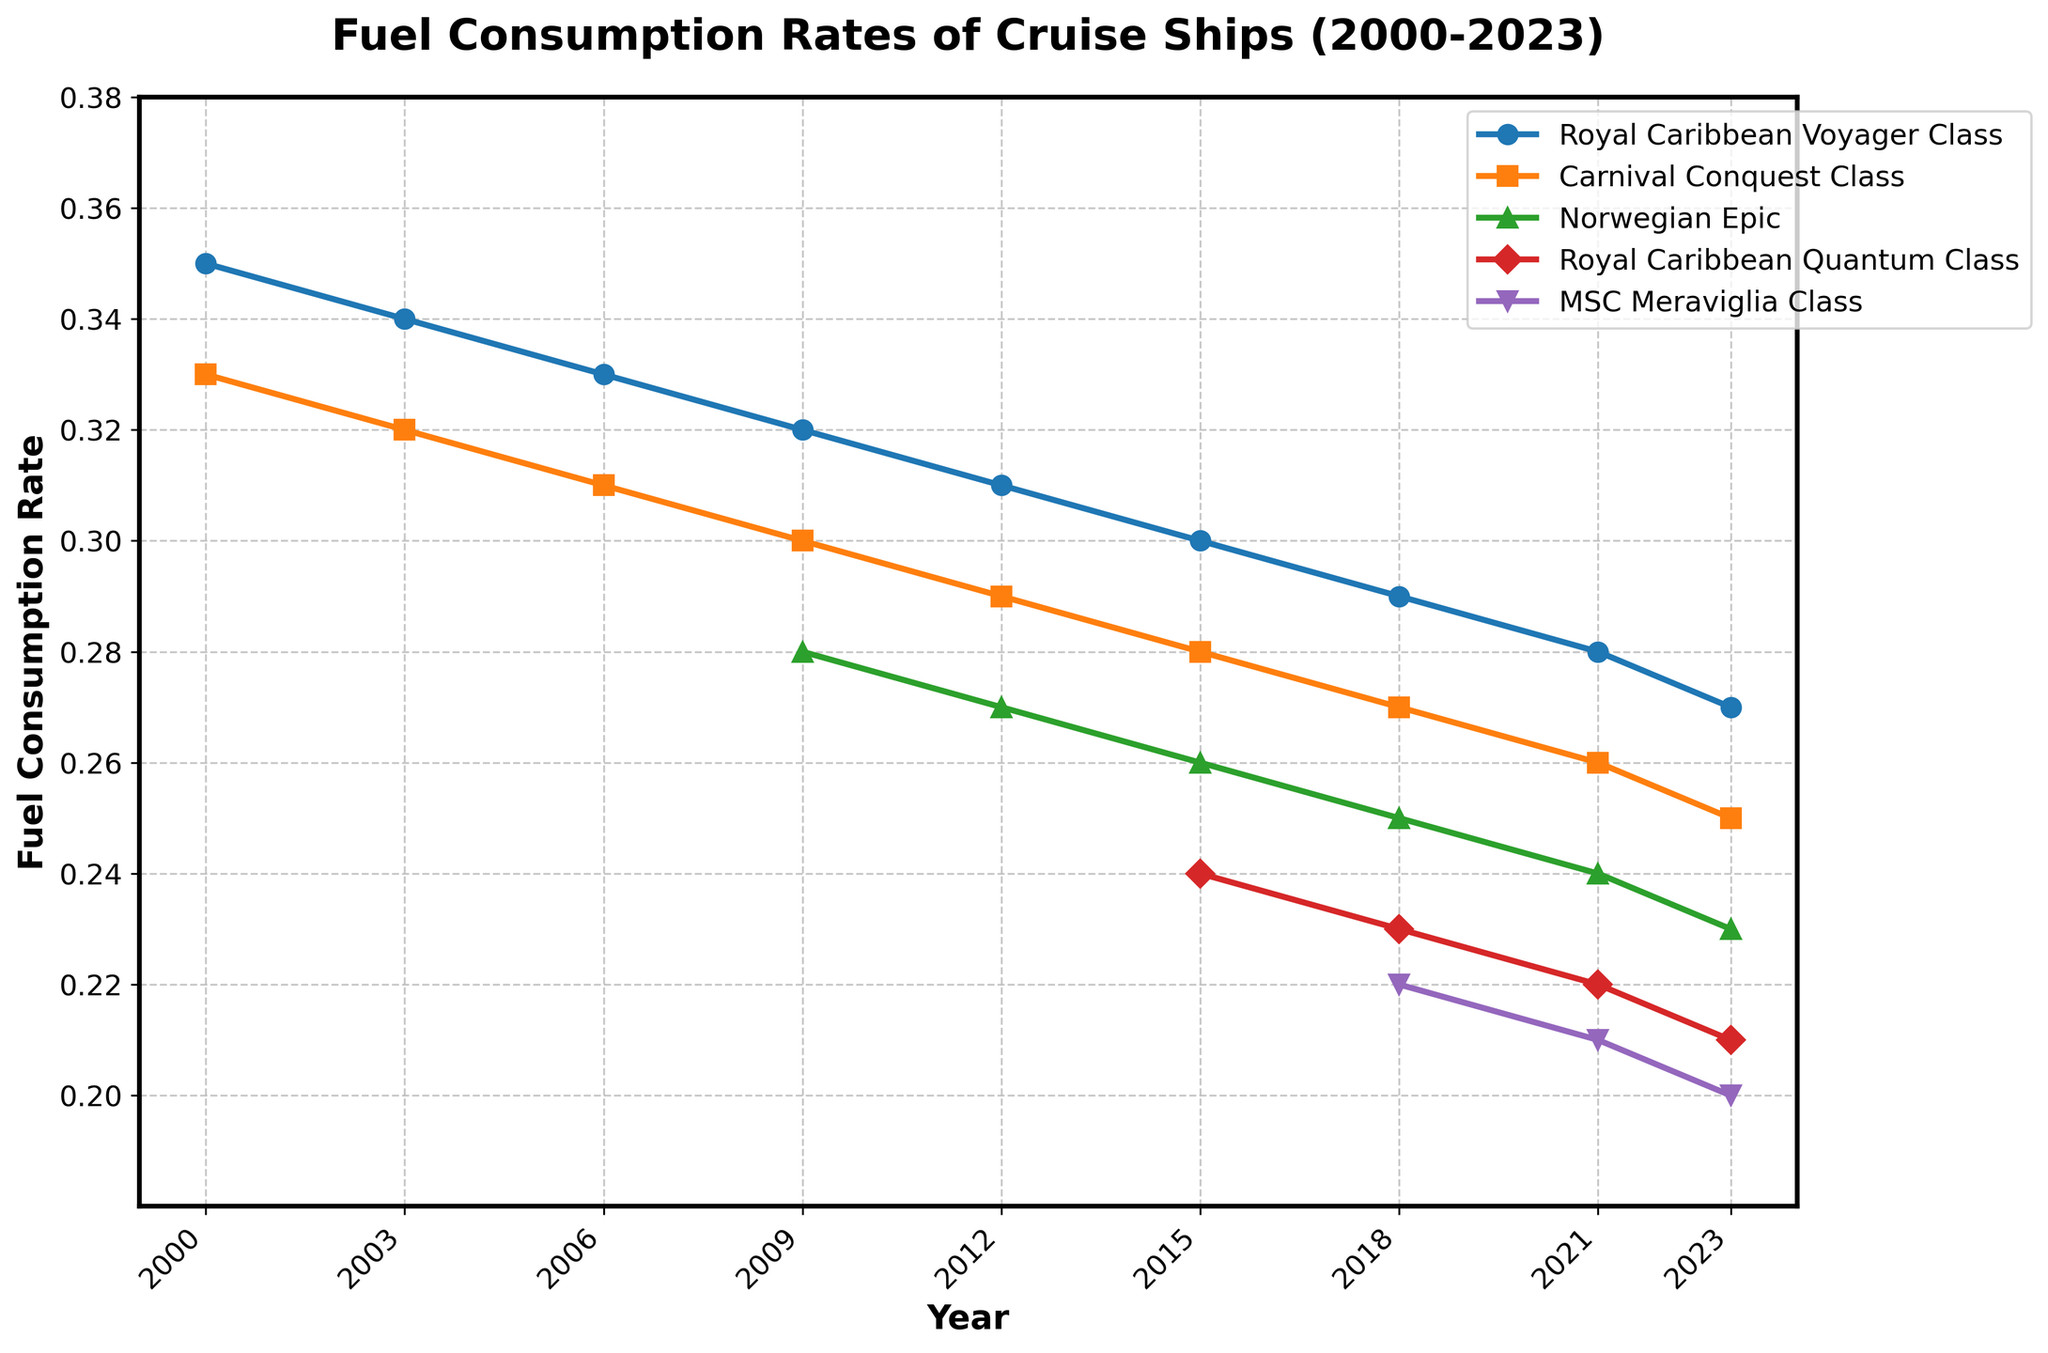Which cruise ship model maintains the highest fuel consumption rate throughout the years? By examining the plot, the Royal Caribbean Voyager Class consistently has the highest line, indicating the highest consumption rate.
Answer: Royal Caribbean Voyager Class Compare the fuel consumption rates of Royal Caribbean Quantum Class and MSC Meraviglia Class in 2023. Which one is more efficient? In 2023, the Royal Caribbean Quantum Class has a consumption rate of 0.21, while MSC Meraviglia Class has a lower rate of 0.20. Lower fuel consumption rate implies more efficiency.
Answer: MSC Meraviglia Class Has the Norwegian Epic model seen a decrease in fuel consumption from 2009 to 2023, and by how much? From the figure, the Norwegian Epic starts with a rate of 0.28 in 2009 and decreases to 0.23 in 2023. Subtracting these values gives the decrease: 0.28 - 0.23 = 0.05.
Answer: 0.05 What is the average fuel consumption rate of the Carnival Conquest Class from 2000 to 2023? The rates from 2000 to 2023 are 0.33, 0.32, 0.31, 0.30, 0.29, 0.28, 0.27, 0.26, and 0.25. Summing these values and dividing by the number of years (9) gives the average: (0.33 + 0.32 + 0.31 + 0.30 + 0.29 + 0.28 + 0.27 + 0.26 + 0.25) / 9 ≈ 0.29.
Answer: 0.29 Which cruise ship model has the most significant decrease in fuel consumption rate from its initial year to 2023? Calculate the initial and final rates for each model: 
- Royal Caribbean Voyager Class: 0.35 - 0.27 = 0.08
- Carnival Conquest Class: 0.33 - 0.25 = 0.08
- Norwegian Epic: 0.28 - 0.23 = 0.05
- Royal Caribbean Quantum Class: 0.24 - 0.21 = 0.03
- MSC Meraviglia Class: 0.22 - 0.20 = 0.02
Both Royal Caribbean Voyager Class and Carnival Conquest Class have the most significant decrease of 0.08.
Answer: Royal Caribbean Voyager Class and Carnival Conquest Class How has the fuel consumption rate trend for traditional models (2000-2009) compared to newer models (2015-2023)? Traditional models, indicated by Royal Caribbean Voyager Class and Carnival Conquest Class, show a gradual decrease from higher rates (0.35 to 0.32 and 0.33 to 0.30). Newer models, exemplified by Royal Caribbean Quantum Class and MSC Meraviglia Class, start with lower initial rates (0.24 and 0.22) and also show a gradual decrease indicating more efficient designs from the beginning.
Answer: Newer models are initially more efficient and continue to improve Between 2018 and 2023, how much did the fuel consumption rate decrease for the Royal Caribbean Quantum Class? The rates for Royal Caribbean Quantum Class in 2018 and 2023 are 0.23 and 0.21 respectively. Subtracting these values gives the decrease: 0.23 - 0.21 = 0.02.
Answer: 0.02 Which model has the steadiest decrease in fuel consumption without any rapid declines? By observing the plots, all models show steady decreases, but the Carnival Conquest Class maintains a particularly steady decrease from 0.33 in 2000 to 0.25 in 2023 without any rapid changes.
Answer: Carnival Conquest Class 